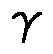Convert formula to latex. <formula><loc_0><loc_0><loc_500><loc_500>\gamma</formula> 